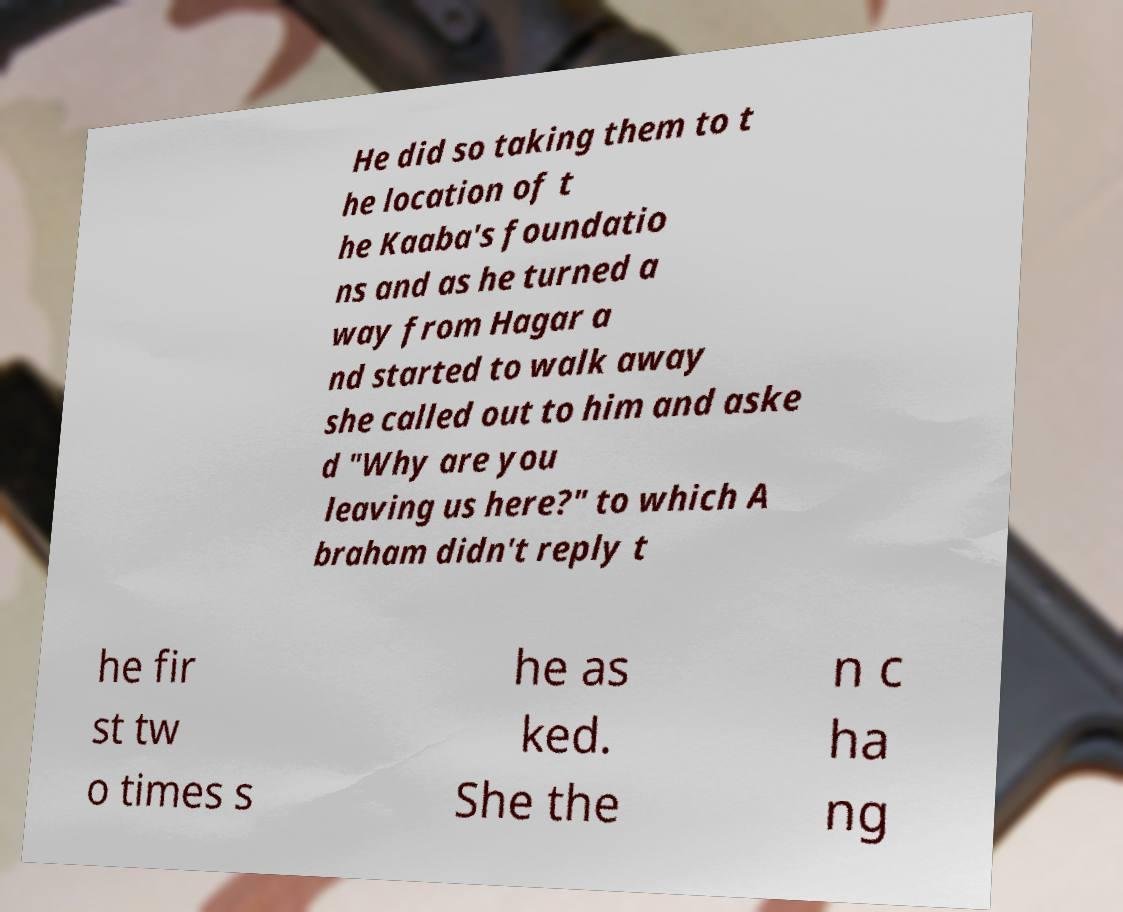Could you assist in decoding the text presented in this image and type it out clearly? He did so taking them to t he location of t he Kaaba's foundatio ns and as he turned a way from Hagar a nd started to walk away she called out to him and aske d "Why are you leaving us here?" to which A braham didn't reply t he fir st tw o times s he as ked. She the n c ha ng 